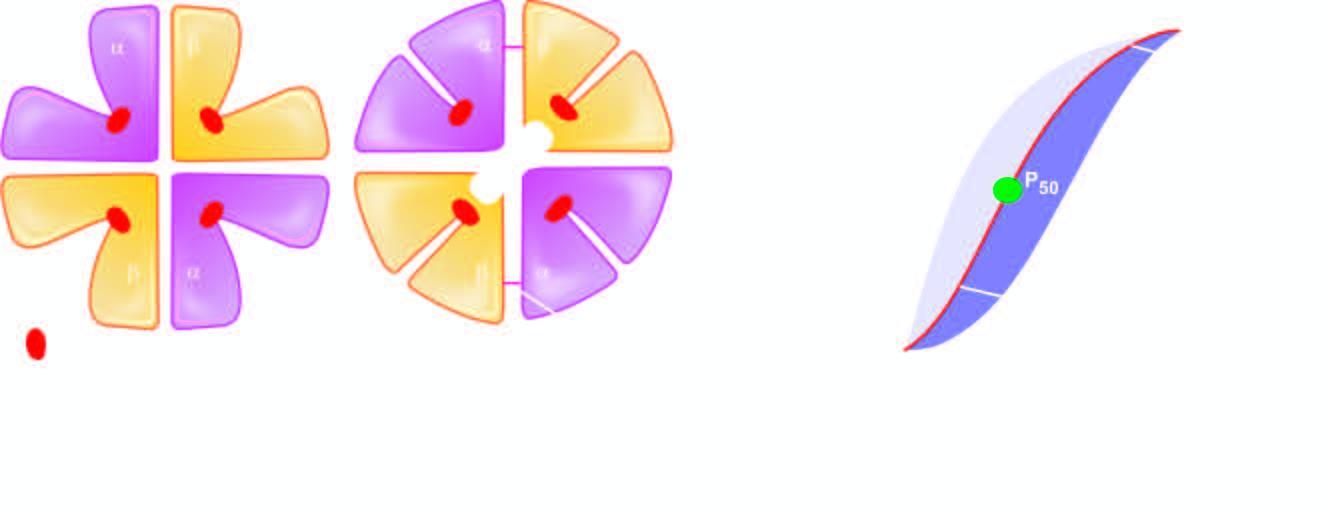what is affected by acidic ph?
Answer the question using a single word or phrase. The shift of the curve to higher oxygen delivery 